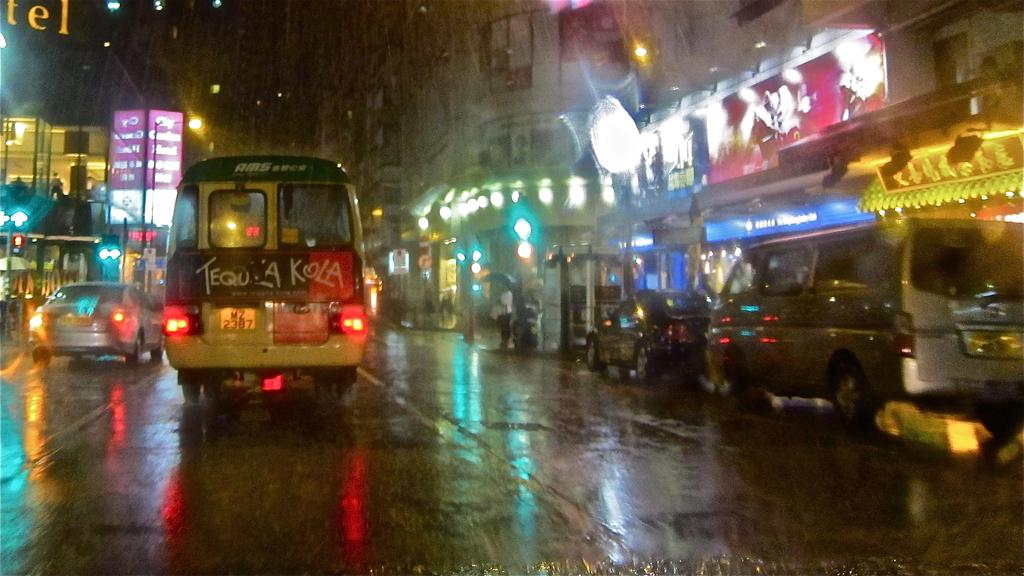<image>
Present a compact description of the photo's key features. A photograph of a busy street in a city shows the back of an AMS bus with the license MZ 2387. 